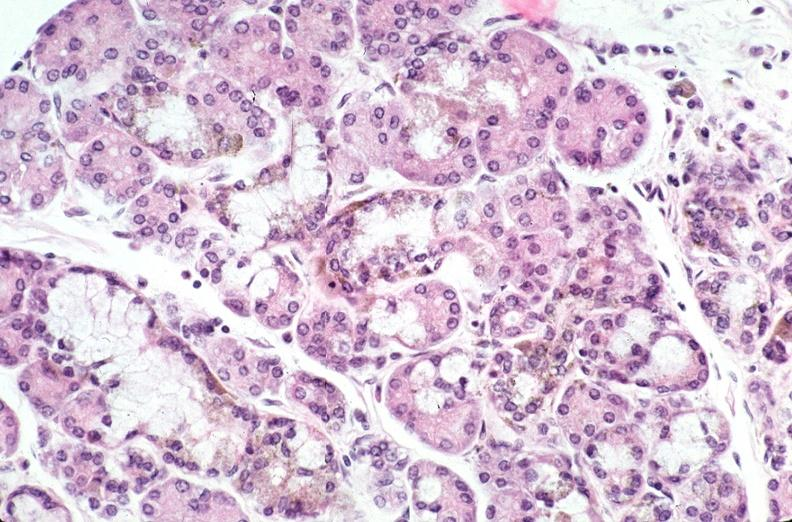what does this image show?
Answer the question using a single word or phrase. Pancreas 